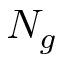<formula> <loc_0><loc_0><loc_500><loc_500>N _ { g }</formula> 